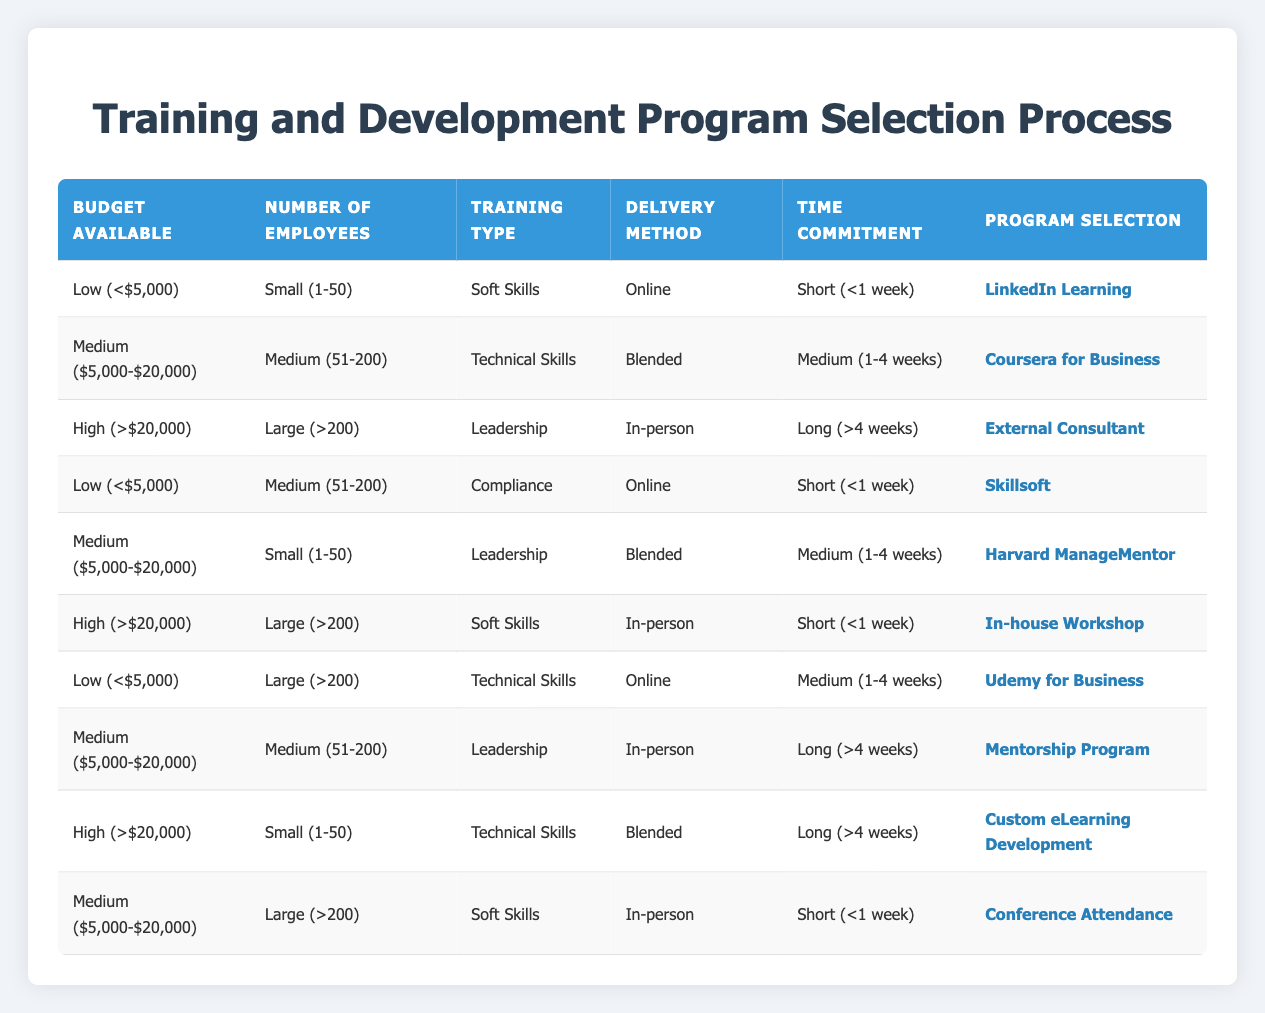What program is recommended for a small group focusing on soft skills with a low budget? The table shows that for a "Budget Available" of "Low (<$5,000)", "Number of Employees" as "Small (1-50)", "Training Type" as "Soft Skills", the recommended program is "LinkedIn Learning".
Answer: LinkedIn Learning Is there an option for leadership training with a medium budget for a large team? According to the table, for a "Budget Available" of "Medium ($5,000-$20,000)", "Number of Employees" as "Large (>200)", and "Training Type" as "Leadership", the program selected is "Mentorship Program".
Answer: Yes What is the selected program for compliance training with a low budget and a medium-sized team? The table indicates that for a "Budget Available" of "Low (<$5,000)", "Number of Employees" as "Medium (51-200)", "Training Type" as "Compliance", the program chosen is "Skillsoft".
Answer: Skillsoft How many distinct programs are listed for high budget allocations? By examining the table, there are three distinct programs for "High (>$20,000)" budget allocations: "External Consultant", "In-house Workshop", and "Custom eLearning Development".
Answer: 3 For large teams with a high budget, what type of training focuses on soft skills? The table lists that for a "Budget Available" of "High (>$20,000)", "Number of Employees" as "Large (>200)", and "Training Type" as "Soft Skills", the program selected is "In-house Workshop".
Answer: In-house Workshop What is the common delivery method for technical skills training in medium-sized teams with medium budgets? The table shows that for "Medium ($5,000-$20,000)" budget and "Medium (51-200)" employees interested in "Technical Skills", the delivery method is "Blended", making it the common method for this category.
Answer: Blended True or false: Compliance training can be delivered online for a small budget and a large employee base. The table confirms there is no entry for compliance training with "Low (<$5,000)" budget and "Large (>200)" employees, meaning the statement is false.
Answer: False What training option is available for technical skills for large teams with a low budget and a medium time commitment? From the table, we see that for a "Budget Available" of "Low (<$5,000)", and "Number of Employees" being "Large (>200)", with a "Time Commitment" of "Medium (1-4 weeks)", the recommended program is "Udemy for Business".
Answer: Udemy for Business 